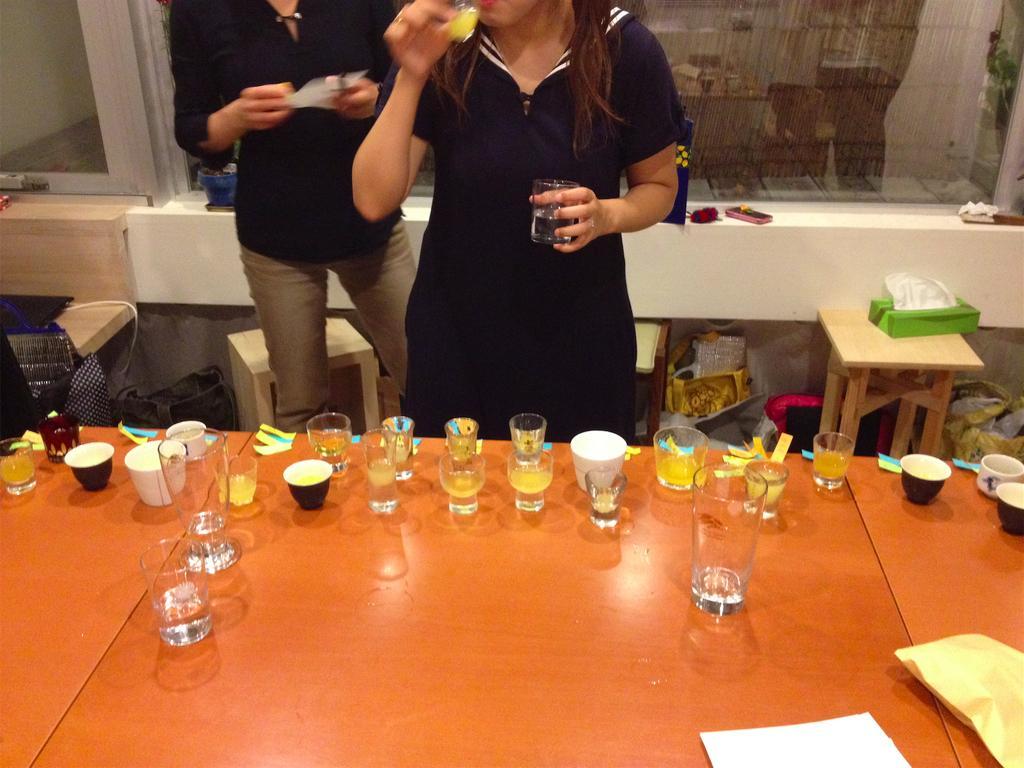How would you summarize this image in a sentence or two? In this picture we can see couple of glasses, cups, and papers on the table, in front of the table a woman is holding a glass in her hand and she is drinking, besides to her we can see a person. 